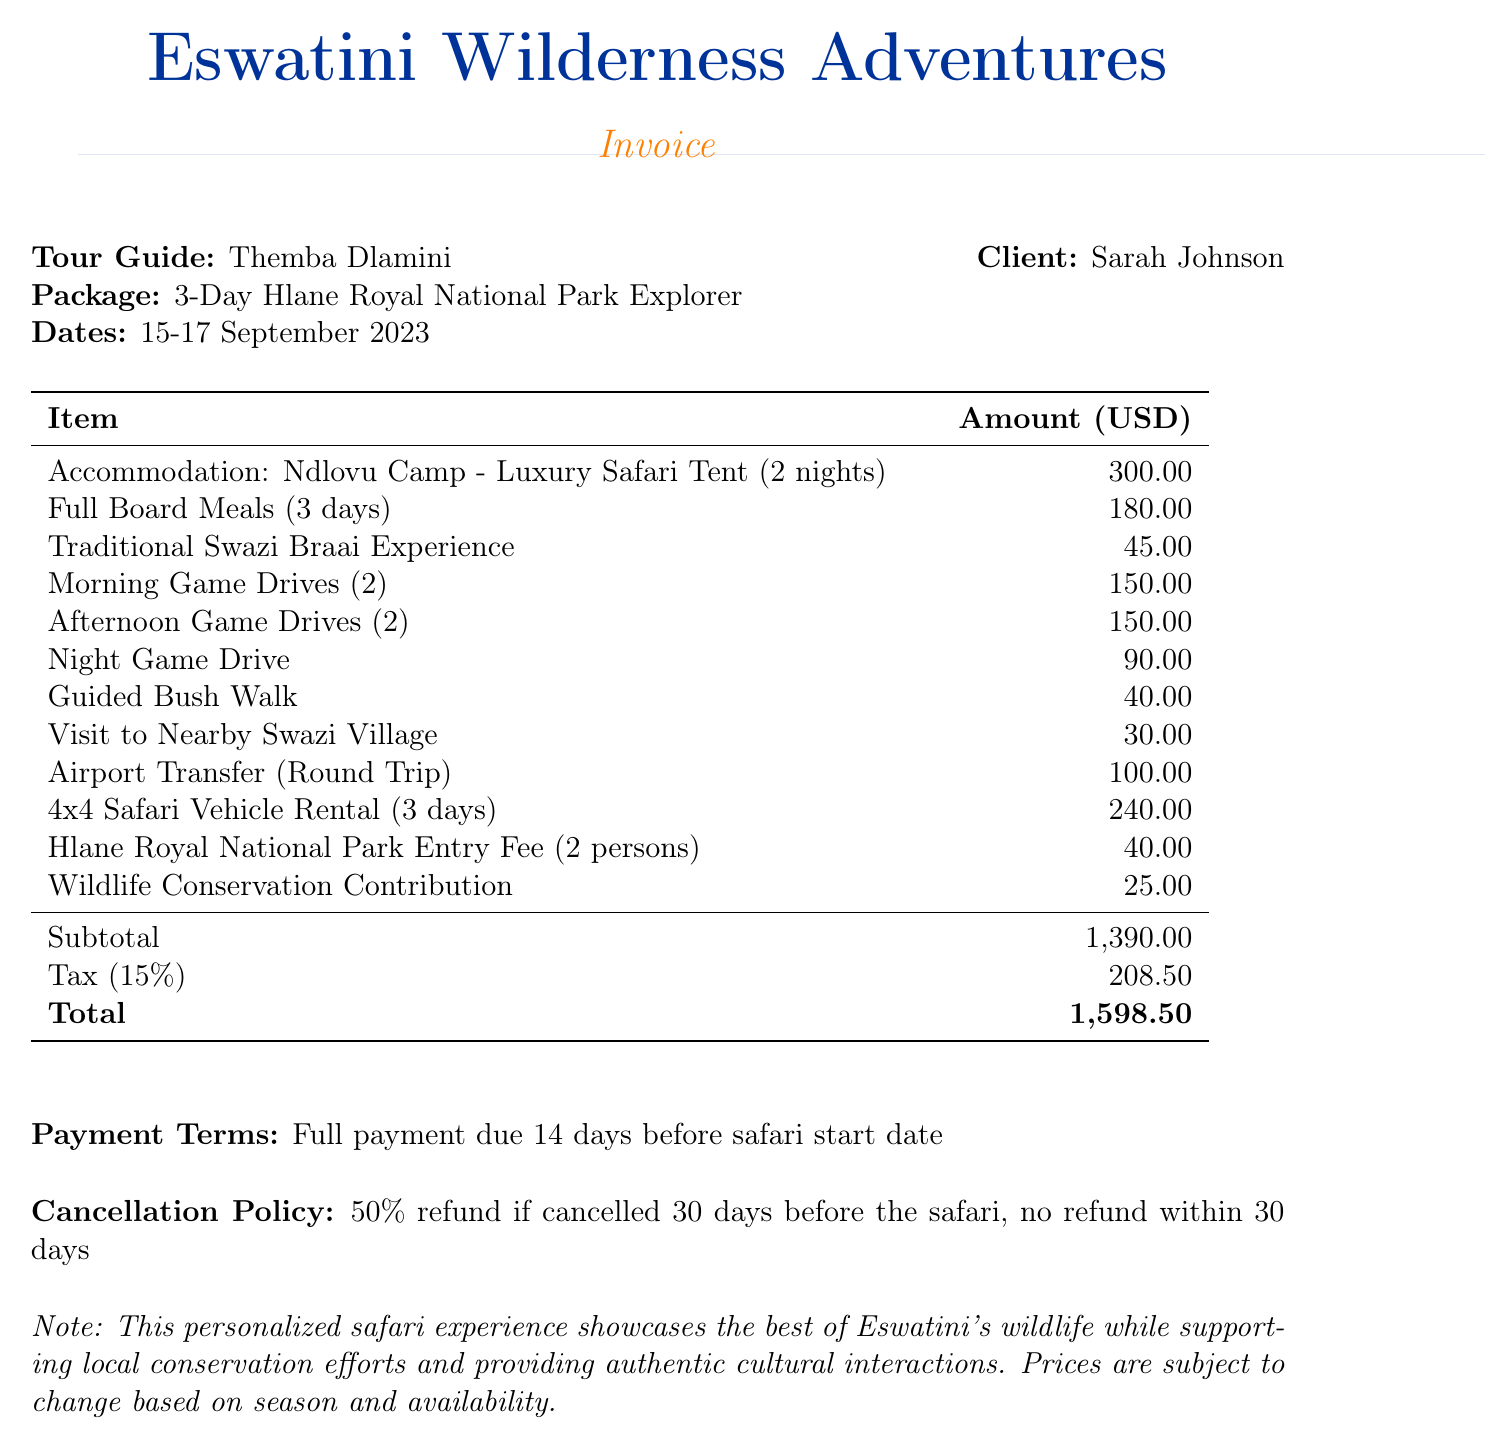What is the company name? The company name is listed at the top of the document under the header.
Answer: Eswatini Wilderness Adventures Who is the tour guide? The tour guide's name is mentioned in the contact information section.
Answer: Themba Dlamini What is the total amount due? The total amount is highlighted in the invoice's summary table at the bottom.
Answer: 1,598.50 How many nights did the client stay at the Ndlovu Camp? The number of nights is specified next to the accommodation item.
Answer: 2 What is included in the full board meals? The meals are listed in the itemized billing and specify inclusivity for all meals.
Answer: Breakfast, Lunch, Dinner What is the quantity of the night game drive? The quantity of the night game drive is provided in the itemized game drive costs.
Answer: 1 What is the cancellation policy for the safari? The cancellation policy outlines the refund conditions provided in the document.
Answer: 50% refund if cancelled 30 days before What is the payment term stated in the document? Payment terms are given in a specific section detailing when payment is due.
Answer: Full payment due 14 days before safari start date What is the subtotal before tax? The subtotal is clearly outlined in the summary section before the tax is added.
Answer: 1,390.00 